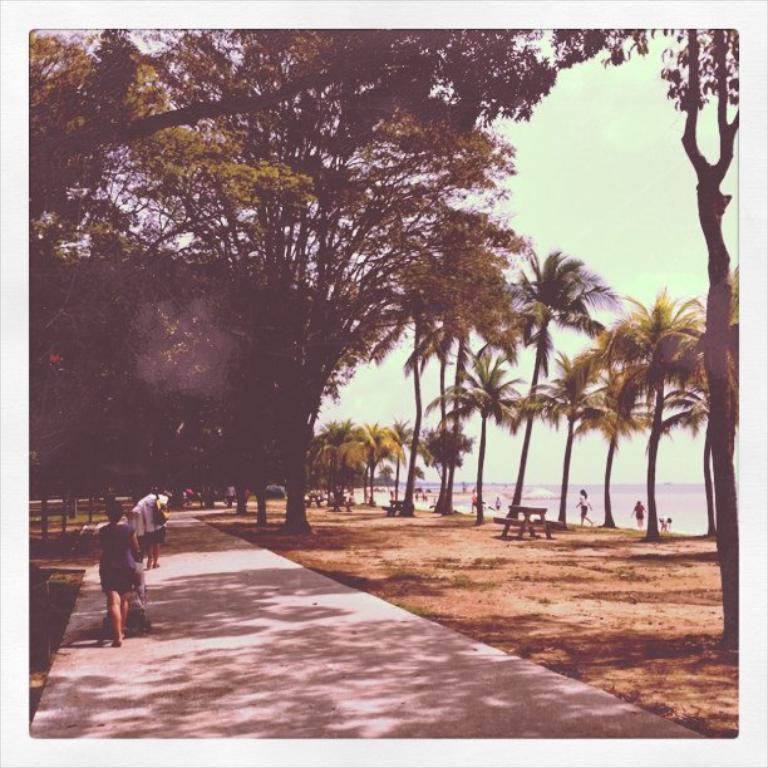In one or two sentences, can you explain what this image depicts? In this picture we can see the group of persons were walking on the street. On the right we can see another group of persons who is standing on the beach. In the background we can see many trees and ocean. At the top there is a sky. 